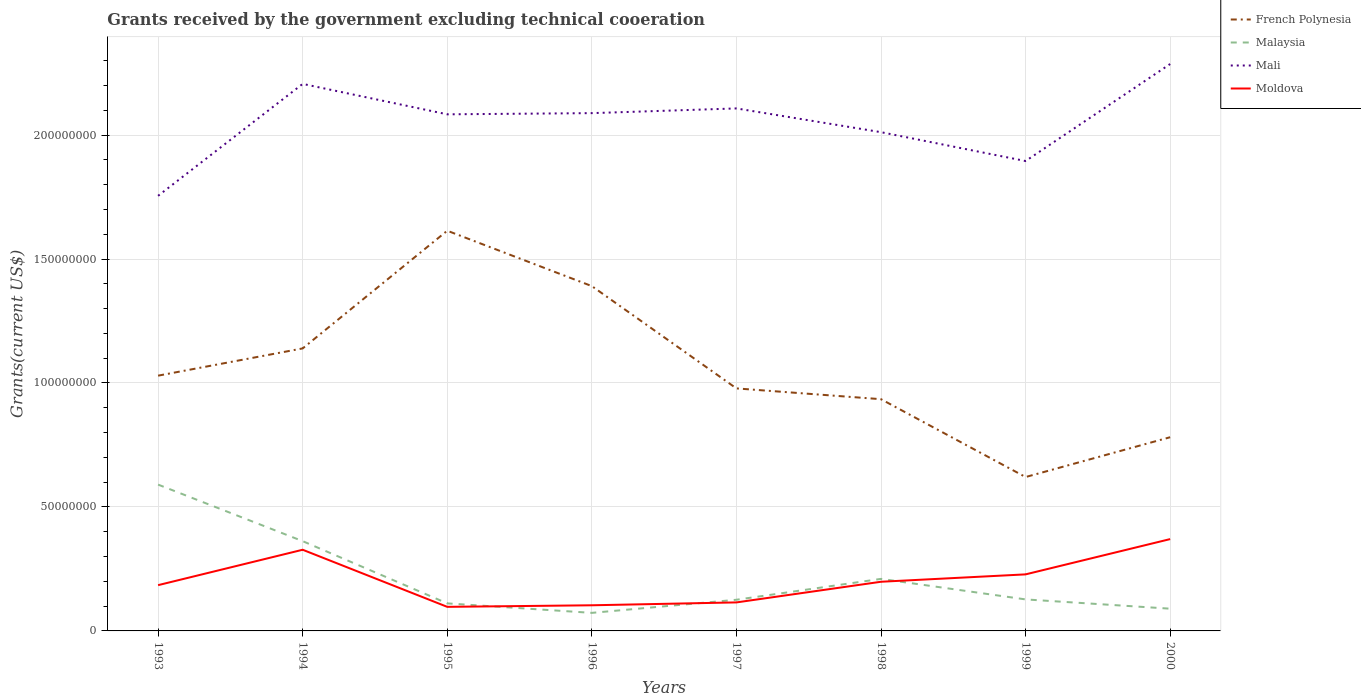How many different coloured lines are there?
Offer a terse response. 4. Does the line corresponding to Malaysia intersect with the line corresponding to French Polynesia?
Offer a terse response. No. Across all years, what is the maximum total grants received by the government in Moldova?
Your answer should be compact. 9.71e+06. What is the total total grants received by the government in Mali in the graph?
Make the answer very short. 7.68e+06. What is the difference between the highest and the second highest total grants received by the government in Moldova?
Give a very brief answer. 2.73e+07. Is the total grants received by the government in Mali strictly greater than the total grants received by the government in French Polynesia over the years?
Provide a succinct answer. No. What is the difference between two consecutive major ticks on the Y-axis?
Your response must be concise. 5.00e+07. Does the graph contain any zero values?
Your answer should be compact. No. Does the graph contain grids?
Make the answer very short. Yes. Where does the legend appear in the graph?
Make the answer very short. Top right. How many legend labels are there?
Your response must be concise. 4. How are the legend labels stacked?
Offer a very short reply. Vertical. What is the title of the graph?
Your answer should be compact. Grants received by the government excluding technical cooeration. Does "Swaziland" appear as one of the legend labels in the graph?
Make the answer very short. No. What is the label or title of the Y-axis?
Your response must be concise. Grants(current US$). What is the Grants(current US$) in French Polynesia in 1993?
Your answer should be compact. 1.03e+08. What is the Grants(current US$) in Malaysia in 1993?
Your answer should be very brief. 5.90e+07. What is the Grants(current US$) in Mali in 1993?
Offer a terse response. 1.76e+08. What is the Grants(current US$) in Moldova in 1993?
Offer a very short reply. 1.85e+07. What is the Grants(current US$) in French Polynesia in 1994?
Your response must be concise. 1.14e+08. What is the Grants(current US$) of Malaysia in 1994?
Your answer should be very brief. 3.62e+07. What is the Grants(current US$) of Mali in 1994?
Offer a very short reply. 2.21e+08. What is the Grants(current US$) of Moldova in 1994?
Provide a succinct answer. 3.27e+07. What is the Grants(current US$) of French Polynesia in 1995?
Keep it short and to the point. 1.61e+08. What is the Grants(current US$) in Malaysia in 1995?
Keep it short and to the point. 1.11e+07. What is the Grants(current US$) of Mali in 1995?
Your answer should be compact. 2.08e+08. What is the Grants(current US$) in Moldova in 1995?
Your response must be concise. 9.71e+06. What is the Grants(current US$) in French Polynesia in 1996?
Your response must be concise. 1.39e+08. What is the Grants(current US$) in Malaysia in 1996?
Your answer should be very brief. 7.28e+06. What is the Grants(current US$) of Mali in 1996?
Offer a terse response. 2.09e+08. What is the Grants(current US$) of Moldova in 1996?
Your response must be concise. 1.03e+07. What is the Grants(current US$) of French Polynesia in 1997?
Keep it short and to the point. 9.78e+07. What is the Grants(current US$) in Malaysia in 1997?
Your answer should be compact. 1.26e+07. What is the Grants(current US$) of Mali in 1997?
Provide a succinct answer. 2.11e+08. What is the Grants(current US$) in Moldova in 1997?
Offer a very short reply. 1.15e+07. What is the Grants(current US$) of French Polynesia in 1998?
Offer a terse response. 9.35e+07. What is the Grants(current US$) of Malaysia in 1998?
Ensure brevity in your answer.  2.10e+07. What is the Grants(current US$) in Mali in 1998?
Provide a succinct answer. 2.01e+08. What is the Grants(current US$) in Moldova in 1998?
Ensure brevity in your answer.  1.98e+07. What is the Grants(current US$) of French Polynesia in 1999?
Your answer should be compact. 6.21e+07. What is the Grants(current US$) of Malaysia in 1999?
Provide a succinct answer. 1.27e+07. What is the Grants(current US$) in Mali in 1999?
Your answer should be very brief. 1.90e+08. What is the Grants(current US$) in Moldova in 1999?
Your response must be concise. 2.28e+07. What is the Grants(current US$) in French Polynesia in 2000?
Your answer should be very brief. 7.81e+07. What is the Grants(current US$) in Malaysia in 2000?
Your response must be concise. 8.97e+06. What is the Grants(current US$) of Mali in 2000?
Your answer should be very brief. 2.29e+08. What is the Grants(current US$) of Moldova in 2000?
Your response must be concise. 3.70e+07. Across all years, what is the maximum Grants(current US$) of French Polynesia?
Provide a succinct answer. 1.61e+08. Across all years, what is the maximum Grants(current US$) of Malaysia?
Provide a short and direct response. 5.90e+07. Across all years, what is the maximum Grants(current US$) in Mali?
Give a very brief answer. 2.29e+08. Across all years, what is the maximum Grants(current US$) of Moldova?
Ensure brevity in your answer.  3.70e+07. Across all years, what is the minimum Grants(current US$) in French Polynesia?
Your answer should be compact. 6.21e+07. Across all years, what is the minimum Grants(current US$) in Malaysia?
Provide a short and direct response. 7.28e+06. Across all years, what is the minimum Grants(current US$) of Mali?
Keep it short and to the point. 1.76e+08. Across all years, what is the minimum Grants(current US$) in Moldova?
Your response must be concise. 9.71e+06. What is the total Grants(current US$) of French Polynesia in the graph?
Provide a short and direct response. 8.49e+08. What is the total Grants(current US$) of Malaysia in the graph?
Make the answer very short. 1.69e+08. What is the total Grants(current US$) in Mali in the graph?
Your answer should be compact. 1.64e+09. What is the total Grants(current US$) of Moldova in the graph?
Offer a very short reply. 1.62e+08. What is the difference between the Grants(current US$) in French Polynesia in 1993 and that in 1994?
Your answer should be very brief. -1.10e+07. What is the difference between the Grants(current US$) in Malaysia in 1993 and that in 1994?
Make the answer very short. 2.28e+07. What is the difference between the Grants(current US$) of Mali in 1993 and that in 1994?
Ensure brevity in your answer.  -4.51e+07. What is the difference between the Grants(current US$) of Moldova in 1993 and that in 1994?
Give a very brief answer. -1.43e+07. What is the difference between the Grants(current US$) in French Polynesia in 1993 and that in 1995?
Keep it short and to the point. -5.85e+07. What is the difference between the Grants(current US$) in Malaysia in 1993 and that in 1995?
Offer a very short reply. 4.79e+07. What is the difference between the Grants(current US$) in Mali in 1993 and that in 1995?
Make the answer very short. -3.29e+07. What is the difference between the Grants(current US$) of Moldova in 1993 and that in 1995?
Your response must be concise. 8.75e+06. What is the difference between the Grants(current US$) in French Polynesia in 1993 and that in 1996?
Give a very brief answer. -3.61e+07. What is the difference between the Grants(current US$) in Malaysia in 1993 and that in 1996?
Provide a succinct answer. 5.17e+07. What is the difference between the Grants(current US$) in Mali in 1993 and that in 1996?
Ensure brevity in your answer.  -3.34e+07. What is the difference between the Grants(current US$) in Moldova in 1993 and that in 1996?
Offer a very short reply. 8.12e+06. What is the difference between the Grants(current US$) of French Polynesia in 1993 and that in 1997?
Provide a short and direct response. 5.14e+06. What is the difference between the Grants(current US$) of Malaysia in 1993 and that in 1997?
Your response must be concise. 4.64e+07. What is the difference between the Grants(current US$) of Mali in 1993 and that in 1997?
Your answer should be compact. -3.52e+07. What is the difference between the Grants(current US$) of Moldova in 1993 and that in 1997?
Keep it short and to the point. 6.96e+06. What is the difference between the Grants(current US$) of French Polynesia in 1993 and that in 1998?
Your answer should be very brief. 9.49e+06. What is the difference between the Grants(current US$) of Malaysia in 1993 and that in 1998?
Keep it short and to the point. 3.80e+07. What is the difference between the Grants(current US$) in Mali in 1993 and that in 1998?
Ensure brevity in your answer.  -2.57e+07. What is the difference between the Grants(current US$) in Moldova in 1993 and that in 1998?
Give a very brief answer. -1.37e+06. What is the difference between the Grants(current US$) in French Polynesia in 1993 and that in 1999?
Give a very brief answer. 4.09e+07. What is the difference between the Grants(current US$) of Malaysia in 1993 and that in 1999?
Provide a succinct answer. 4.63e+07. What is the difference between the Grants(current US$) in Mali in 1993 and that in 1999?
Offer a very short reply. -1.40e+07. What is the difference between the Grants(current US$) in Moldova in 1993 and that in 1999?
Provide a short and direct response. -4.35e+06. What is the difference between the Grants(current US$) of French Polynesia in 1993 and that in 2000?
Your answer should be very brief. 2.48e+07. What is the difference between the Grants(current US$) in Malaysia in 1993 and that in 2000?
Offer a very short reply. 5.00e+07. What is the difference between the Grants(current US$) of Mali in 1993 and that in 2000?
Your answer should be very brief. -5.32e+07. What is the difference between the Grants(current US$) in Moldova in 1993 and that in 2000?
Ensure brevity in your answer.  -1.86e+07. What is the difference between the Grants(current US$) of French Polynesia in 1994 and that in 1995?
Your response must be concise. -4.75e+07. What is the difference between the Grants(current US$) of Malaysia in 1994 and that in 1995?
Offer a very short reply. 2.51e+07. What is the difference between the Grants(current US$) in Mali in 1994 and that in 1995?
Your answer should be very brief. 1.23e+07. What is the difference between the Grants(current US$) in Moldova in 1994 and that in 1995?
Offer a terse response. 2.30e+07. What is the difference between the Grants(current US$) in French Polynesia in 1994 and that in 1996?
Keep it short and to the point. -2.51e+07. What is the difference between the Grants(current US$) of Malaysia in 1994 and that in 1996?
Your response must be concise. 2.89e+07. What is the difference between the Grants(current US$) in Mali in 1994 and that in 1996?
Ensure brevity in your answer.  1.18e+07. What is the difference between the Grants(current US$) of Moldova in 1994 and that in 1996?
Give a very brief answer. 2.24e+07. What is the difference between the Grants(current US$) of French Polynesia in 1994 and that in 1997?
Your answer should be compact. 1.61e+07. What is the difference between the Grants(current US$) in Malaysia in 1994 and that in 1997?
Your answer should be very brief. 2.36e+07. What is the difference between the Grants(current US$) of Mali in 1994 and that in 1997?
Your response must be concise. 9.89e+06. What is the difference between the Grants(current US$) in Moldova in 1994 and that in 1997?
Provide a succinct answer. 2.12e+07. What is the difference between the Grants(current US$) of French Polynesia in 1994 and that in 1998?
Provide a short and direct response. 2.05e+07. What is the difference between the Grants(current US$) of Malaysia in 1994 and that in 1998?
Your answer should be very brief. 1.52e+07. What is the difference between the Grants(current US$) in Mali in 1994 and that in 1998?
Give a very brief answer. 1.95e+07. What is the difference between the Grants(current US$) of Moldova in 1994 and that in 1998?
Keep it short and to the point. 1.29e+07. What is the difference between the Grants(current US$) of French Polynesia in 1994 and that in 1999?
Your response must be concise. 5.19e+07. What is the difference between the Grants(current US$) in Malaysia in 1994 and that in 1999?
Provide a succinct answer. 2.35e+07. What is the difference between the Grants(current US$) in Mali in 1994 and that in 1999?
Offer a terse response. 3.11e+07. What is the difference between the Grants(current US$) in Moldova in 1994 and that in 1999?
Provide a succinct answer. 9.93e+06. What is the difference between the Grants(current US$) in French Polynesia in 1994 and that in 2000?
Provide a succinct answer. 3.58e+07. What is the difference between the Grants(current US$) of Malaysia in 1994 and that in 2000?
Offer a terse response. 2.72e+07. What is the difference between the Grants(current US$) in Mali in 1994 and that in 2000?
Give a very brief answer. -8.02e+06. What is the difference between the Grants(current US$) in Moldova in 1994 and that in 2000?
Keep it short and to the point. -4.30e+06. What is the difference between the Grants(current US$) of French Polynesia in 1995 and that in 1996?
Keep it short and to the point. 2.23e+07. What is the difference between the Grants(current US$) of Malaysia in 1995 and that in 1996?
Offer a terse response. 3.83e+06. What is the difference between the Grants(current US$) in Mali in 1995 and that in 1996?
Provide a succinct answer. -4.80e+05. What is the difference between the Grants(current US$) of Moldova in 1995 and that in 1996?
Your response must be concise. -6.30e+05. What is the difference between the Grants(current US$) of French Polynesia in 1995 and that in 1997?
Offer a terse response. 6.36e+07. What is the difference between the Grants(current US$) of Malaysia in 1995 and that in 1997?
Keep it short and to the point. -1.46e+06. What is the difference between the Grants(current US$) of Mali in 1995 and that in 1997?
Your response must be concise. -2.38e+06. What is the difference between the Grants(current US$) of Moldova in 1995 and that in 1997?
Offer a very short reply. -1.79e+06. What is the difference between the Grants(current US$) of French Polynesia in 1995 and that in 1998?
Your response must be concise. 6.80e+07. What is the difference between the Grants(current US$) of Malaysia in 1995 and that in 1998?
Offer a terse response. -9.88e+06. What is the difference between the Grants(current US$) of Mali in 1995 and that in 1998?
Offer a terse response. 7.20e+06. What is the difference between the Grants(current US$) of Moldova in 1995 and that in 1998?
Offer a terse response. -1.01e+07. What is the difference between the Grants(current US$) of French Polynesia in 1995 and that in 1999?
Make the answer very short. 9.94e+07. What is the difference between the Grants(current US$) in Malaysia in 1995 and that in 1999?
Make the answer very short. -1.60e+06. What is the difference between the Grants(current US$) in Mali in 1995 and that in 1999?
Your answer should be compact. 1.88e+07. What is the difference between the Grants(current US$) of Moldova in 1995 and that in 1999?
Give a very brief answer. -1.31e+07. What is the difference between the Grants(current US$) in French Polynesia in 1995 and that in 2000?
Your answer should be very brief. 8.33e+07. What is the difference between the Grants(current US$) of Malaysia in 1995 and that in 2000?
Provide a succinct answer. 2.14e+06. What is the difference between the Grants(current US$) in Mali in 1995 and that in 2000?
Offer a terse response. -2.03e+07. What is the difference between the Grants(current US$) in Moldova in 1995 and that in 2000?
Offer a very short reply. -2.73e+07. What is the difference between the Grants(current US$) of French Polynesia in 1996 and that in 1997?
Give a very brief answer. 4.13e+07. What is the difference between the Grants(current US$) of Malaysia in 1996 and that in 1997?
Provide a succinct answer. -5.29e+06. What is the difference between the Grants(current US$) of Mali in 1996 and that in 1997?
Your answer should be compact. -1.90e+06. What is the difference between the Grants(current US$) of Moldova in 1996 and that in 1997?
Make the answer very short. -1.16e+06. What is the difference between the Grants(current US$) of French Polynesia in 1996 and that in 1998?
Your answer should be very brief. 4.56e+07. What is the difference between the Grants(current US$) in Malaysia in 1996 and that in 1998?
Provide a succinct answer. -1.37e+07. What is the difference between the Grants(current US$) of Mali in 1996 and that in 1998?
Your answer should be very brief. 7.68e+06. What is the difference between the Grants(current US$) in Moldova in 1996 and that in 1998?
Offer a terse response. -9.49e+06. What is the difference between the Grants(current US$) in French Polynesia in 1996 and that in 1999?
Your answer should be compact. 7.70e+07. What is the difference between the Grants(current US$) in Malaysia in 1996 and that in 1999?
Offer a very short reply. -5.43e+06. What is the difference between the Grants(current US$) in Mali in 1996 and that in 1999?
Provide a short and direct response. 1.93e+07. What is the difference between the Grants(current US$) of Moldova in 1996 and that in 1999?
Give a very brief answer. -1.25e+07. What is the difference between the Grants(current US$) of French Polynesia in 1996 and that in 2000?
Keep it short and to the point. 6.10e+07. What is the difference between the Grants(current US$) of Malaysia in 1996 and that in 2000?
Give a very brief answer. -1.69e+06. What is the difference between the Grants(current US$) in Mali in 1996 and that in 2000?
Provide a succinct answer. -1.98e+07. What is the difference between the Grants(current US$) of Moldova in 1996 and that in 2000?
Provide a succinct answer. -2.67e+07. What is the difference between the Grants(current US$) in French Polynesia in 1997 and that in 1998?
Provide a succinct answer. 4.35e+06. What is the difference between the Grants(current US$) in Malaysia in 1997 and that in 1998?
Provide a short and direct response. -8.42e+06. What is the difference between the Grants(current US$) in Mali in 1997 and that in 1998?
Offer a terse response. 9.58e+06. What is the difference between the Grants(current US$) in Moldova in 1997 and that in 1998?
Offer a very short reply. -8.33e+06. What is the difference between the Grants(current US$) of French Polynesia in 1997 and that in 1999?
Make the answer very short. 3.58e+07. What is the difference between the Grants(current US$) of Malaysia in 1997 and that in 1999?
Your answer should be very brief. -1.40e+05. What is the difference between the Grants(current US$) in Mali in 1997 and that in 1999?
Provide a succinct answer. 2.12e+07. What is the difference between the Grants(current US$) in Moldova in 1997 and that in 1999?
Your answer should be very brief. -1.13e+07. What is the difference between the Grants(current US$) in French Polynesia in 1997 and that in 2000?
Provide a short and direct response. 1.97e+07. What is the difference between the Grants(current US$) of Malaysia in 1997 and that in 2000?
Your answer should be very brief. 3.60e+06. What is the difference between the Grants(current US$) in Mali in 1997 and that in 2000?
Offer a very short reply. -1.79e+07. What is the difference between the Grants(current US$) of Moldova in 1997 and that in 2000?
Offer a very short reply. -2.55e+07. What is the difference between the Grants(current US$) of French Polynesia in 1998 and that in 1999?
Your answer should be very brief. 3.14e+07. What is the difference between the Grants(current US$) of Malaysia in 1998 and that in 1999?
Provide a short and direct response. 8.28e+06. What is the difference between the Grants(current US$) of Mali in 1998 and that in 1999?
Provide a short and direct response. 1.16e+07. What is the difference between the Grants(current US$) in Moldova in 1998 and that in 1999?
Provide a succinct answer. -2.98e+06. What is the difference between the Grants(current US$) of French Polynesia in 1998 and that in 2000?
Your response must be concise. 1.53e+07. What is the difference between the Grants(current US$) in Malaysia in 1998 and that in 2000?
Provide a succinct answer. 1.20e+07. What is the difference between the Grants(current US$) in Mali in 1998 and that in 2000?
Make the answer very short. -2.75e+07. What is the difference between the Grants(current US$) of Moldova in 1998 and that in 2000?
Make the answer very short. -1.72e+07. What is the difference between the Grants(current US$) in French Polynesia in 1999 and that in 2000?
Ensure brevity in your answer.  -1.61e+07. What is the difference between the Grants(current US$) in Malaysia in 1999 and that in 2000?
Provide a short and direct response. 3.74e+06. What is the difference between the Grants(current US$) in Mali in 1999 and that in 2000?
Your answer should be compact. -3.91e+07. What is the difference between the Grants(current US$) of Moldova in 1999 and that in 2000?
Give a very brief answer. -1.42e+07. What is the difference between the Grants(current US$) in French Polynesia in 1993 and the Grants(current US$) in Malaysia in 1994?
Ensure brevity in your answer.  6.68e+07. What is the difference between the Grants(current US$) of French Polynesia in 1993 and the Grants(current US$) of Mali in 1994?
Your answer should be very brief. -1.18e+08. What is the difference between the Grants(current US$) of French Polynesia in 1993 and the Grants(current US$) of Moldova in 1994?
Provide a short and direct response. 7.02e+07. What is the difference between the Grants(current US$) in Malaysia in 1993 and the Grants(current US$) in Mali in 1994?
Provide a short and direct response. -1.62e+08. What is the difference between the Grants(current US$) in Malaysia in 1993 and the Grants(current US$) in Moldova in 1994?
Keep it short and to the point. 2.63e+07. What is the difference between the Grants(current US$) in Mali in 1993 and the Grants(current US$) in Moldova in 1994?
Your answer should be compact. 1.43e+08. What is the difference between the Grants(current US$) of French Polynesia in 1993 and the Grants(current US$) of Malaysia in 1995?
Provide a succinct answer. 9.18e+07. What is the difference between the Grants(current US$) in French Polynesia in 1993 and the Grants(current US$) in Mali in 1995?
Offer a very short reply. -1.05e+08. What is the difference between the Grants(current US$) of French Polynesia in 1993 and the Grants(current US$) of Moldova in 1995?
Ensure brevity in your answer.  9.32e+07. What is the difference between the Grants(current US$) of Malaysia in 1993 and the Grants(current US$) of Mali in 1995?
Give a very brief answer. -1.49e+08. What is the difference between the Grants(current US$) in Malaysia in 1993 and the Grants(current US$) in Moldova in 1995?
Give a very brief answer. 4.93e+07. What is the difference between the Grants(current US$) in Mali in 1993 and the Grants(current US$) in Moldova in 1995?
Your response must be concise. 1.66e+08. What is the difference between the Grants(current US$) in French Polynesia in 1993 and the Grants(current US$) in Malaysia in 1996?
Your response must be concise. 9.57e+07. What is the difference between the Grants(current US$) of French Polynesia in 1993 and the Grants(current US$) of Mali in 1996?
Make the answer very short. -1.06e+08. What is the difference between the Grants(current US$) in French Polynesia in 1993 and the Grants(current US$) in Moldova in 1996?
Ensure brevity in your answer.  9.26e+07. What is the difference between the Grants(current US$) of Malaysia in 1993 and the Grants(current US$) of Mali in 1996?
Offer a very short reply. -1.50e+08. What is the difference between the Grants(current US$) in Malaysia in 1993 and the Grants(current US$) in Moldova in 1996?
Your response must be concise. 4.87e+07. What is the difference between the Grants(current US$) in Mali in 1993 and the Grants(current US$) in Moldova in 1996?
Provide a short and direct response. 1.65e+08. What is the difference between the Grants(current US$) in French Polynesia in 1993 and the Grants(current US$) in Malaysia in 1997?
Keep it short and to the point. 9.04e+07. What is the difference between the Grants(current US$) in French Polynesia in 1993 and the Grants(current US$) in Mali in 1997?
Your answer should be compact. -1.08e+08. What is the difference between the Grants(current US$) of French Polynesia in 1993 and the Grants(current US$) of Moldova in 1997?
Make the answer very short. 9.15e+07. What is the difference between the Grants(current US$) in Malaysia in 1993 and the Grants(current US$) in Mali in 1997?
Your answer should be very brief. -1.52e+08. What is the difference between the Grants(current US$) in Malaysia in 1993 and the Grants(current US$) in Moldova in 1997?
Your answer should be compact. 4.75e+07. What is the difference between the Grants(current US$) in Mali in 1993 and the Grants(current US$) in Moldova in 1997?
Your answer should be compact. 1.64e+08. What is the difference between the Grants(current US$) in French Polynesia in 1993 and the Grants(current US$) in Malaysia in 1998?
Offer a terse response. 8.20e+07. What is the difference between the Grants(current US$) in French Polynesia in 1993 and the Grants(current US$) in Mali in 1998?
Keep it short and to the point. -9.82e+07. What is the difference between the Grants(current US$) in French Polynesia in 1993 and the Grants(current US$) in Moldova in 1998?
Your response must be concise. 8.31e+07. What is the difference between the Grants(current US$) in Malaysia in 1993 and the Grants(current US$) in Mali in 1998?
Give a very brief answer. -1.42e+08. What is the difference between the Grants(current US$) of Malaysia in 1993 and the Grants(current US$) of Moldova in 1998?
Your answer should be very brief. 3.92e+07. What is the difference between the Grants(current US$) of Mali in 1993 and the Grants(current US$) of Moldova in 1998?
Ensure brevity in your answer.  1.56e+08. What is the difference between the Grants(current US$) in French Polynesia in 1993 and the Grants(current US$) in Malaysia in 1999?
Make the answer very short. 9.02e+07. What is the difference between the Grants(current US$) in French Polynesia in 1993 and the Grants(current US$) in Mali in 1999?
Give a very brief answer. -8.66e+07. What is the difference between the Grants(current US$) in French Polynesia in 1993 and the Grants(current US$) in Moldova in 1999?
Your answer should be very brief. 8.02e+07. What is the difference between the Grants(current US$) of Malaysia in 1993 and the Grants(current US$) of Mali in 1999?
Offer a very short reply. -1.31e+08. What is the difference between the Grants(current US$) of Malaysia in 1993 and the Grants(current US$) of Moldova in 1999?
Keep it short and to the point. 3.62e+07. What is the difference between the Grants(current US$) of Mali in 1993 and the Grants(current US$) of Moldova in 1999?
Your answer should be compact. 1.53e+08. What is the difference between the Grants(current US$) of French Polynesia in 1993 and the Grants(current US$) of Malaysia in 2000?
Ensure brevity in your answer.  9.40e+07. What is the difference between the Grants(current US$) of French Polynesia in 1993 and the Grants(current US$) of Mali in 2000?
Offer a very short reply. -1.26e+08. What is the difference between the Grants(current US$) of French Polynesia in 1993 and the Grants(current US$) of Moldova in 2000?
Offer a very short reply. 6.59e+07. What is the difference between the Grants(current US$) in Malaysia in 1993 and the Grants(current US$) in Mali in 2000?
Offer a very short reply. -1.70e+08. What is the difference between the Grants(current US$) in Malaysia in 1993 and the Grants(current US$) in Moldova in 2000?
Provide a short and direct response. 2.20e+07. What is the difference between the Grants(current US$) of Mali in 1993 and the Grants(current US$) of Moldova in 2000?
Offer a very short reply. 1.38e+08. What is the difference between the Grants(current US$) in French Polynesia in 1994 and the Grants(current US$) in Malaysia in 1995?
Your answer should be very brief. 1.03e+08. What is the difference between the Grants(current US$) of French Polynesia in 1994 and the Grants(current US$) of Mali in 1995?
Ensure brevity in your answer.  -9.44e+07. What is the difference between the Grants(current US$) in French Polynesia in 1994 and the Grants(current US$) in Moldova in 1995?
Keep it short and to the point. 1.04e+08. What is the difference between the Grants(current US$) of Malaysia in 1994 and the Grants(current US$) of Mali in 1995?
Offer a terse response. -1.72e+08. What is the difference between the Grants(current US$) of Malaysia in 1994 and the Grants(current US$) of Moldova in 1995?
Give a very brief answer. 2.65e+07. What is the difference between the Grants(current US$) of Mali in 1994 and the Grants(current US$) of Moldova in 1995?
Keep it short and to the point. 2.11e+08. What is the difference between the Grants(current US$) of French Polynesia in 1994 and the Grants(current US$) of Malaysia in 1996?
Provide a short and direct response. 1.07e+08. What is the difference between the Grants(current US$) of French Polynesia in 1994 and the Grants(current US$) of Mali in 1996?
Give a very brief answer. -9.49e+07. What is the difference between the Grants(current US$) of French Polynesia in 1994 and the Grants(current US$) of Moldova in 1996?
Provide a short and direct response. 1.04e+08. What is the difference between the Grants(current US$) in Malaysia in 1994 and the Grants(current US$) in Mali in 1996?
Your answer should be very brief. -1.73e+08. What is the difference between the Grants(current US$) in Malaysia in 1994 and the Grants(current US$) in Moldova in 1996?
Keep it short and to the point. 2.59e+07. What is the difference between the Grants(current US$) in Mali in 1994 and the Grants(current US$) in Moldova in 1996?
Your response must be concise. 2.10e+08. What is the difference between the Grants(current US$) of French Polynesia in 1994 and the Grants(current US$) of Malaysia in 1997?
Make the answer very short. 1.01e+08. What is the difference between the Grants(current US$) of French Polynesia in 1994 and the Grants(current US$) of Mali in 1997?
Your answer should be compact. -9.68e+07. What is the difference between the Grants(current US$) in French Polynesia in 1994 and the Grants(current US$) in Moldova in 1997?
Provide a short and direct response. 1.02e+08. What is the difference between the Grants(current US$) of Malaysia in 1994 and the Grants(current US$) of Mali in 1997?
Your answer should be very brief. -1.75e+08. What is the difference between the Grants(current US$) of Malaysia in 1994 and the Grants(current US$) of Moldova in 1997?
Provide a succinct answer. 2.47e+07. What is the difference between the Grants(current US$) in Mali in 1994 and the Grants(current US$) in Moldova in 1997?
Offer a very short reply. 2.09e+08. What is the difference between the Grants(current US$) of French Polynesia in 1994 and the Grants(current US$) of Malaysia in 1998?
Keep it short and to the point. 9.30e+07. What is the difference between the Grants(current US$) in French Polynesia in 1994 and the Grants(current US$) in Mali in 1998?
Make the answer very short. -8.72e+07. What is the difference between the Grants(current US$) of French Polynesia in 1994 and the Grants(current US$) of Moldova in 1998?
Make the answer very short. 9.41e+07. What is the difference between the Grants(current US$) of Malaysia in 1994 and the Grants(current US$) of Mali in 1998?
Ensure brevity in your answer.  -1.65e+08. What is the difference between the Grants(current US$) in Malaysia in 1994 and the Grants(current US$) in Moldova in 1998?
Your answer should be very brief. 1.64e+07. What is the difference between the Grants(current US$) in Mali in 1994 and the Grants(current US$) in Moldova in 1998?
Ensure brevity in your answer.  2.01e+08. What is the difference between the Grants(current US$) of French Polynesia in 1994 and the Grants(current US$) of Malaysia in 1999?
Make the answer very short. 1.01e+08. What is the difference between the Grants(current US$) in French Polynesia in 1994 and the Grants(current US$) in Mali in 1999?
Ensure brevity in your answer.  -7.56e+07. What is the difference between the Grants(current US$) of French Polynesia in 1994 and the Grants(current US$) of Moldova in 1999?
Offer a very short reply. 9.11e+07. What is the difference between the Grants(current US$) in Malaysia in 1994 and the Grants(current US$) in Mali in 1999?
Provide a short and direct response. -1.53e+08. What is the difference between the Grants(current US$) in Malaysia in 1994 and the Grants(current US$) in Moldova in 1999?
Give a very brief answer. 1.34e+07. What is the difference between the Grants(current US$) in Mali in 1994 and the Grants(current US$) in Moldova in 1999?
Provide a succinct answer. 1.98e+08. What is the difference between the Grants(current US$) in French Polynesia in 1994 and the Grants(current US$) in Malaysia in 2000?
Your answer should be very brief. 1.05e+08. What is the difference between the Grants(current US$) of French Polynesia in 1994 and the Grants(current US$) of Mali in 2000?
Keep it short and to the point. -1.15e+08. What is the difference between the Grants(current US$) in French Polynesia in 1994 and the Grants(current US$) in Moldova in 2000?
Provide a succinct answer. 7.69e+07. What is the difference between the Grants(current US$) in Malaysia in 1994 and the Grants(current US$) in Mali in 2000?
Ensure brevity in your answer.  -1.92e+08. What is the difference between the Grants(current US$) of Malaysia in 1994 and the Grants(current US$) of Moldova in 2000?
Keep it short and to the point. -8.30e+05. What is the difference between the Grants(current US$) of Mali in 1994 and the Grants(current US$) of Moldova in 2000?
Give a very brief answer. 1.84e+08. What is the difference between the Grants(current US$) in French Polynesia in 1995 and the Grants(current US$) in Malaysia in 1996?
Provide a short and direct response. 1.54e+08. What is the difference between the Grants(current US$) of French Polynesia in 1995 and the Grants(current US$) of Mali in 1996?
Ensure brevity in your answer.  -4.74e+07. What is the difference between the Grants(current US$) of French Polynesia in 1995 and the Grants(current US$) of Moldova in 1996?
Make the answer very short. 1.51e+08. What is the difference between the Grants(current US$) in Malaysia in 1995 and the Grants(current US$) in Mali in 1996?
Give a very brief answer. -1.98e+08. What is the difference between the Grants(current US$) in Malaysia in 1995 and the Grants(current US$) in Moldova in 1996?
Give a very brief answer. 7.70e+05. What is the difference between the Grants(current US$) in Mali in 1995 and the Grants(current US$) in Moldova in 1996?
Your answer should be very brief. 1.98e+08. What is the difference between the Grants(current US$) in French Polynesia in 1995 and the Grants(current US$) in Malaysia in 1997?
Offer a terse response. 1.49e+08. What is the difference between the Grants(current US$) of French Polynesia in 1995 and the Grants(current US$) of Mali in 1997?
Ensure brevity in your answer.  -4.93e+07. What is the difference between the Grants(current US$) of French Polynesia in 1995 and the Grants(current US$) of Moldova in 1997?
Provide a succinct answer. 1.50e+08. What is the difference between the Grants(current US$) in Malaysia in 1995 and the Grants(current US$) in Mali in 1997?
Offer a very short reply. -2.00e+08. What is the difference between the Grants(current US$) of Malaysia in 1995 and the Grants(current US$) of Moldova in 1997?
Ensure brevity in your answer.  -3.90e+05. What is the difference between the Grants(current US$) of Mali in 1995 and the Grants(current US$) of Moldova in 1997?
Ensure brevity in your answer.  1.97e+08. What is the difference between the Grants(current US$) of French Polynesia in 1995 and the Grants(current US$) of Malaysia in 1998?
Give a very brief answer. 1.40e+08. What is the difference between the Grants(current US$) in French Polynesia in 1995 and the Grants(current US$) in Mali in 1998?
Give a very brief answer. -3.98e+07. What is the difference between the Grants(current US$) of French Polynesia in 1995 and the Grants(current US$) of Moldova in 1998?
Ensure brevity in your answer.  1.42e+08. What is the difference between the Grants(current US$) in Malaysia in 1995 and the Grants(current US$) in Mali in 1998?
Ensure brevity in your answer.  -1.90e+08. What is the difference between the Grants(current US$) of Malaysia in 1995 and the Grants(current US$) of Moldova in 1998?
Your answer should be compact. -8.72e+06. What is the difference between the Grants(current US$) in Mali in 1995 and the Grants(current US$) in Moldova in 1998?
Ensure brevity in your answer.  1.89e+08. What is the difference between the Grants(current US$) of French Polynesia in 1995 and the Grants(current US$) of Malaysia in 1999?
Your response must be concise. 1.49e+08. What is the difference between the Grants(current US$) in French Polynesia in 1995 and the Grants(current US$) in Mali in 1999?
Provide a succinct answer. -2.81e+07. What is the difference between the Grants(current US$) of French Polynesia in 1995 and the Grants(current US$) of Moldova in 1999?
Provide a short and direct response. 1.39e+08. What is the difference between the Grants(current US$) of Malaysia in 1995 and the Grants(current US$) of Mali in 1999?
Offer a terse response. -1.78e+08. What is the difference between the Grants(current US$) of Malaysia in 1995 and the Grants(current US$) of Moldova in 1999?
Your response must be concise. -1.17e+07. What is the difference between the Grants(current US$) of Mali in 1995 and the Grants(current US$) of Moldova in 1999?
Your answer should be compact. 1.86e+08. What is the difference between the Grants(current US$) in French Polynesia in 1995 and the Grants(current US$) in Malaysia in 2000?
Give a very brief answer. 1.52e+08. What is the difference between the Grants(current US$) in French Polynesia in 1995 and the Grants(current US$) in Mali in 2000?
Provide a succinct answer. -6.72e+07. What is the difference between the Grants(current US$) of French Polynesia in 1995 and the Grants(current US$) of Moldova in 2000?
Make the answer very short. 1.24e+08. What is the difference between the Grants(current US$) in Malaysia in 1995 and the Grants(current US$) in Mali in 2000?
Make the answer very short. -2.18e+08. What is the difference between the Grants(current US$) of Malaysia in 1995 and the Grants(current US$) of Moldova in 2000?
Keep it short and to the point. -2.59e+07. What is the difference between the Grants(current US$) in Mali in 1995 and the Grants(current US$) in Moldova in 2000?
Give a very brief answer. 1.71e+08. What is the difference between the Grants(current US$) in French Polynesia in 1996 and the Grants(current US$) in Malaysia in 1997?
Offer a terse response. 1.27e+08. What is the difference between the Grants(current US$) in French Polynesia in 1996 and the Grants(current US$) in Mali in 1997?
Provide a succinct answer. -7.17e+07. What is the difference between the Grants(current US$) in French Polynesia in 1996 and the Grants(current US$) in Moldova in 1997?
Give a very brief answer. 1.28e+08. What is the difference between the Grants(current US$) of Malaysia in 1996 and the Grants(current US$) of Mali in 1997?
Your response must be concise. -2.03e+08. What is the difference between the Grants(current US$) of Malaysia in 1996 and the Grants(current US$) of Moldova in 1997?
Provide a short and direct response. -4.22e+06. What is the difference between the Grants(current US$) of Mali in 1996 and the Grants(current US$) of Moldova in 1997?
Offer a terse response. 1.97e+08. What is the difference between the Grants(current US$) of French Polynesia in 1996 and the Grants(current US$) of Malaysia in 1998?
Ensure brevity in your answer.  1.18e+08. What is the difference between the Grants(current US$) in French Polynesia in 1996 and the Grants(current US$) in Mali in 1998?
Ensure brevity in your answer.  -6.21e+07. What is the difference between the Grants(current US$) of French Polynesia in 1996 and the Grants(current US$) of Moldova in 1998?
Provide a succinct answer. 1.19e+08. What is the difference between the Grants(current US$) of Malaysia in 1996 and the Grants(current US$) of Mali in 1998?
Give a very brief answer. -1.94e+08. What is the difference between the Grants(current US$) in Malaysia in 1996 and the Grants(current US$) in Moldova in 1998?
Keep it short and to the point. -1.26e+07. What is the difference between the Grants(current US$) in Mali in 1996 and the Grants(current US$) in Moldova in 1998?
Keep it short and to the point. 1.89e+08. What is the difference between the Grants(current US$) in French Polynesia in 1996 and the Grants(current US$) in Malaysia in 1999?
Keep it short and to the point. 1.26e+08. What is the difference between the Grants(current US$) in French Polynesia in 1996 and the Grants(current US$) in Mali in 1999?
Provide a succinct answer. -5.04e+07. What is the difference between the Grants(current US$) of French Polynesia in 1996 and the Grants(current US$) of Moldova in 1999?
Your answer should be very brief. 1.16e+08. What is the difference between the Grants(current US$) in Malaysia in 1996 and the Grants(current US$) in Mali in 1999?
Provide a succinct answer. -1.82e+08. What is the difference between the Grants(current US$) in Malaysia in 1996 and the Grants(current US$) in Moldova in 1999?
Offer a terse response. -1.55e+07. What is the difference between the Grants(current US$) of Mali in 1996 and the Grants(current US$) of Moldova in 1999?
Your answer should be compact. 1.86e+08. What is the difference between the Grants(current US$) of French Polynesia in 1996 and the Grants(current US$) of Malaysia in 2000?
Offer a very short reply. 1.30e+08. What is the difference between the Grants(current US$) of French Polynesia in 1996 and the Grants(current US$) of Mali in 2000?
Provide a short and direct response. -8.96e+07. What is the difference between the Grants(current US$) of French Polynesia in 1996 and the Grants(current US$) of Moldova in 2000?
Your response must be concise. 1.02e+08. What is the difference between the Grants(current US$) of Malaysia in 1996 and the Grants(current US$) of Mali in 2000?
Provide a succinct answer. -2.21e+08. What is the difference between the Grants(current US$) of Malaysia in 1996 and the Grants(current US$) of Moldova in 2000?
Your answer should be compact. -2.98e+07. What is the difference between the Grants(current US$) of Mali in 1996 and the Grants(current US$) of Moldova in 2000?
Your answer should be very brief. 1.72e+08. What is the difference between the Grants(current US$) of French Polynesia in 1997 and the Grants(current US$) of Malaysia in 1998?
Offer a terse response. 7.68e+07. What is the difference between the Grants(current US$) of French Polynesia in 1997 and the Grants(current US$) of Mali in 1998?
Keep it short and to the point. -1.03e+08. What is the difference between the Grants(current US$) in French Polynesia in 1997 and the Grants(current US$) in Moldova in 1998?
Make the answer very short. 7.80e+07. What is the difference between the Grants(current US$) in Malaysia in 1997 and the Grants(current US$) in Mali in 1998?
Your answer should be compact. -1.89e+08. What is the difference between the Grants(current US$) in Malaysia in 1997 and the Grants(current US$) in Moldova in 1998?
Your answer should be very brief. -7.26e+06. What is the difference between the Grants(current US$) in Mali in 1997 and the Grants(current US$) in Moldova in 1998?
Offer a terse response. 1.91e+08. What is the difference between the Grants(current US$) in French Polynesia in 1997 and the Grants(current US$) in Malaysia in 1999?
Make the answer very short. 8.51e+07. What is the difference between the Grants(current US$) of French Polynesia in 1997 and the Grants(current US$) of Mali in 1999?
Ensure brevity in your answer.  -9.17e+07. What is the difference between the Grants(current US$) of French Polynesia in 1997 and the Grants(current US$) of Moldova in 1999?
Give a very brief answer. 7.50e+07. What is the difference between the Grants(current US$) in Malaysia in 1997 and the Grants(current US$) in Mali in 1999?
Make the answer very short. -1.77e+08. What is the difference between the Grants(current US$) in Malaysia in 1997 and the Grants(current US$) in Moldova in 1999?
Make the answer very short. -1.02e+07. What is the difference between the Grants(current US$) of Mali in 1997 and the Grants(current US$) of Moldova in 1999?
Give a very brief answer. 1.88e+08. What is the difference between the Grants(current US$) of French Polynesia in 1997 and the Grants(current US$) of Malaysia in 2000?
Your response must be concise. 8.88e+07. What is the difference between the Grants(current US$) of French Polynesia in 1997 and the Grants(current US$) of Mali in 2000?
Your answer should be compact. -1.31e+08. What is the difference between the Grants(current US$) of French Polynesia in 1997 and the Grants(current US$) of Moldova in 2000?
Keep it short and to the point. 6.08e+07. What is the difference between the Grants(current US$) of Malaysia in 1997 and the Grants(current US$) of Mali in 2000?
Offer a very short reply. -2.16e+08. What is the difference between the Grants(current US$) of Malaysia in 1997 and the Grants(current US$) of Moldova in 2000?
Your response must be concise. -2.45e+07. What is the difference between the Grants(current US$) in Mali in 1997 and the Grants(current US$) in Moldova in 2000?
Offer a very short reply. 1.74e+08. What is the difference between the Grants(current US$) of French Polynesia in 1998 and the Grants(current US$) of Malaysia in 1999?
Your answer should be very brief. 8.08e+07. What is the difference between the Grants(current US$) of French Polynesia in 1998 and the Grants(current US$) of Mali in 1999?
Keep it short and to the point. -9.61e+07. What is the difference between the Grants(current US$) of French Polynesia in 1998 and the Grants(current US$) of Moldova in 1999?
Provide a short and direct response. 7.07e+07. What is the difference between the Grants(current US$) of Malaysia in 1998 and the Grants(current US$) of Mali in 1999?
Provide a succinct answer. -1.69e+08. What is the difference between the Grants(current US$) in Malaysia in 1998 and the Grants(current US$) in Moldova in 1999?
Offer a very short reply. -1.82e+06. What is the difference between the Grants(current US$) in Mali in 1998 and the Grants(current US$) in Moldova in 1999?
Offer a terse response. 1.78e+08. What is the difference between the Grants(current US$) in French Polynesia in 1998 and the Grants(current US$) in Malaysia in 2000?
Your answer should be compact. 8.45e+07. What is the difference between the Grants(current US$) of French Polynesia in 1998 and the Grants(current US$) of Mali in 2000?
Your response must be concise. -1.35e+08. What is the difference between the Grants(current US$) in French Polynesia in 1998 and the Grants(current US$) in Moldova in 2000?
Your answer should be compact. 5.64e+07. What is the difference between the Grants(current US$) in Malaysia in 1998 and the Grants(current US$) in Mali in 2000?
Provide a short and direct response. -2.08e+08. What is the difference between the Grants(current US$) in Malaysia in 1998 and the Grants(current US$) in Moldova in 2000?
Your answer should be very brief. -1.60e+07. What is the difference between the Grants(current US$) of Mali in 1998 and the Grants(current US$) of Moldova in 2000?
Provide a short and direct response. 1.64e+08. What is the difference between the Grants(current US$) in French Polynesia in 1999 and the Grants(current US$) in Malaysia in 2000?
Ensure brevity in your answer.  5.31e+07. What is the difference between the Grants(current US$) of French Polynesia in 1999 and the Grants(current US$) of Mali in 2000?
Offer a terse response. -1.67e+08. What is the difference between the Grants(current US$) in French Polynesia in 1999 and the Grants(current US$) in Moldova in 2000?
Provide a short and direct response. 2.50e+07. What is the difference between the Grants(current US$) of Malaysia in 1999 and the Grants(current US$) of Mali in 2000?
Give a very brief answer. -2.16e+08. What is the difference between the Grants(current US$) of Malaysia in 1999 and the Grants(current US$) of Moldova in 2000?
Provide a succinct answer. -2.43e+07. What is the difference between the Grants(current US$) in Mali in 1999 and the Grants(current US$) in Moldova in 2000?
Provide a succinct answer. 1.52e+08. What is the average Grants(current US$) in French Polynesia per year?
Offer a very short reply. 1.06e+08. What is the average Grants(current US$) in Malaysia per year?
Your response must be concise. 2.11e+07. What is the average Grants(current US$) of Mali per year?
Offer a terse response. 2.05e+08. What is the average Grants(current US$) of Moldova per year?
Offer a very short reply. 2.03e+07. In the year 1993, what is the difference between the Grants(current US$) of French Polynesia and Grants(current US$) of Malaysia?
Keep it short and to the point. 4.39e+07. In the year 1993, what is the difference between the Grants(current US$) in French Polynesia and Grants(current US$) in Mali?
Offer a very short reply. -7.25e+07. In the year 1993, what is the difference between the Grants(current US$) in French Polynesia and Grants(current US$) in Moldova?
Give a very brief answer. 8.45e+07. In the year 1993, what is the difference between the Grants(current US$) in Malaysia and Grants(current US$) in Mali?
Your answer should be compact. -1.16e+08. In the year 1993, what is the difference between the Grants(current US$) of Malaysia and Grants(current US$) of Moldova?
Provide a short and direct response. 4.06e+07. In the year 1993, what is the difference between the Grants(current US$) in Mali and Grants(current US$) in Moldova?
Offer a very short reply. 1.57e+08. In the year 1994, what is the difference between the Grants(current US$) of French Polynesia and Grants(current US$) of Malaysia?
Your response must be concise. 7.77e+07. In the year 1994, what is the difference between the Grants(current US$) of French Polynesia and Grants(current US$) of Mali?
Give a very brief answer. -1.07e+08. In the year 1994, what is the difference between the Grants(current US$) of French Polynesia and Grants(current US$) of Moldova?
Ensure brevity in your answer.  8.12e+07. In the year 1994, what is the difference between the Grants(current US$) of Malaysia and Grants(current US$) of Mali?
Your answer should be compact. -1.84e+08. In the year 1994, what is the difference between the Grants(current US$) in Malaysia and Grants(current US$) in Moldova?
Keep it short and to the point. 3.47e+06. In the year 1994, what is the difference between the Grants(current US$) of Mali and Grants(current US$) of Moldova?
Provide a short and direct response. 1.88e+08. In the year 1995, what is the difference between the Grants(current US$) in French Polynesia and Grants(current US$) in Malaysia?
Make the answer very short. 1.50e+08. In the year 1995, what is the difference between the Grants(current US$) in French Polynesia and Grants(current US$) in Mali?
Make the answer very short. -4.70e+07. In the year 1995, what is the difference between the Grants(current US$) in French Polynesia and Grants(current US$) in Moldova?
Offer a terse response. 1.52e+08. In the year 1995, what is the difference between the Grants(current US$) of Malaysia and Grants(current US$) of Mali?
Your answer should be compact. -1.97e+08. In the year 1995, what is the difference between the Grants(current US$) in Malaysia and Grants(current US$) in Moldova?
Keep it short and to the point. 1.40e+06. In the year 1995, what is the difference between the Grants(current US$) in Mali and Grants(current US$) in Moldova?
Ensure brevity in your answer.  1.99e+08. In the year 1996, what is the difference between the Grants(current US$) in French Polynesia and Grants(current US$) in Malaysia?
Your answer should be compact. 1.32e+08. In the year 1996, what is the difference between the Grants(current US$) in French Polynesia and Grants(current US$) in Mali?
Offer a very short reply. -6.98e+07. In the year 1996, what is the difference between the Grants(current US$) of French Polynesia and Grants(current US$) of Moldova?
Keep it short and to the point. 1.29e+08. In the year 1996, what is the difference between the Grants(current US$) in Malaysia and Grants(current US$) in Mali?
Your answer should be very brief. -2.02e+08. In the year 1996, what is the difference between the Grants(current US$) in Malaysia and Grants(current US$) in Moldova?
Your response must be concise. -3.06e+06. In the year 1996, what is the difference between the Grants(current US$) in Mali and Grants(current US$) in Moldova?
Offer a very short reply. 1.99e+08. In the year 1997, what is the difference between the Grants(current US$) in French Polynesia and Grants(current US$) in Malaysia?
Offer a very short reply. 8.52e+07. In the year 1997, what is the difference between the Grants(current US$) in French Polynesia and Grants(current US$) in Mali?
Ensure brevity in your answer.  -1.13e+08. In the year 1997, what is the difference between the Grants(current US$) of French Polynesia and Grants(current US$) of Moldova?
Ensure brevity in your answer.  8.63e+07. In the year 1997, what is the difference between the Grants(current US$) in Malaysia and Grants(current US$) in Mali?
Give a very brief answer. -1.98e+08. In the year 1997, what is the difference between the Grants(current US$) in Malaysia and Grants(current US$) in Moldova?
Offer a terse response. 1.07e+06. In the year 1997, what is the difference between the Grants(current US$) in Mali and Grants(current US$) in Moldova?
Make the answer very short. 1.99e+08. In the year 1998, what is the difference between the Grants(current US$) in French Polynesia and Grants(current US$) in Malaysia?
Your answer should be very brief. 7.25e+07. In the year 1998, what is the difference between the Grants(current US$) in French Polynesia and Grants(current US$) in Mali?
Your answer should be very brief. -1.08e+08. In the year 1998, what is the difference between the Grants(current US$) of French Polynesia and Grants(current US$) of Moldova?
Provide a succinct answer. 7.36e+07. In the year 1998, what is the difference between the Grants(current US$) of Malaysia and Grants(current US$) of Mali?
Provide a succinct answer. -1.80e+08. In the year 1998, what is the difference between the Grants(current US$) of Malaysia and Grants(current US$) of Moldova?
Your response must be concise. 1.16e+06. In the year 1998, what is the difference between the Grants(current US$) of Mali and Grants(current US$) of Moldova?
Offer a terse response. 1.81e+08. In the year 1999, what is the difference between the Grants(current US$) in French Polynesia and Grants(current US$) in Malaysia?
Ensure brevity in your answer.  4.94e+07. In the year 1999, what is the difference between the Grants(current US$) in French Polynesia and Grants(current US$) in Mali?
Make the answer very short. -1.27e+08. In the year 1999, what is the difference between the Grants(current US$) in French Polynesia and Grants(current US$) in Moldova?
Your response must be concise. 3.93e+07. In the year 1999, what is the difference between the Grants(current US$) of Malaysia and Grants(current US$) of Mali?
Your answer should be very brief. -1.77e+08. In the year 1999, what is the difference between the Grants(current US$) in Malaysia and Grants(current US$) in Moldova?
Offer a very short reply. -1.01e+07. In the year 1999, what is the difference between the Grants(current US$) in Mali and Grants(current US$) in Moldova?
Your response must be concise. 1.67e+08. In the year 2000, what is the difference between the Grants(current US$) in French Polynesia and Grants(current US$) in Malaysia?
Give a very brief answer. 6.92e+07. In the year 2000, what is the difference between the Grants(current US$) in French Polynesia and Grants(current US$) in Mali?
Provide a succinct answer. -1.51e+08. In the year 2000, what is the difference between the Grants(current US$) in French Polynesia and Grants(current US$) in Moldova?
Your answer should be compact. 4.11e+07. In the year 2000, what is the difference between the Grants(current US$) in Malaysia and Grants(current US$) in Mali?
Keep it short and to the point. -2.20e+08. In the year 2000, what is the difference between the Grants(current US$) in Malaysia and Grants(current US$) in Moldova?
Ensure brevity in your answer.  -2.81e+07. In the year 2000, what is the difference between the Grants(current US$) of Mali and Grants(current US$) of Moldova?
Offer a very short reply. 1.92e+08. What is the ratio of the Grants(current US$) in French Polynesia in 1993 to that in 1994?
Your response must be concise. 0.9. What is the ratio of the Grants(current US$) in Malaysia in 1993 to that in 1994?
Ensure brevity in your answer.  1.63. What is the ratio of the Grants(current US$) in Mali in 1993 to that in 1994?
Ensure brevity in your answer.  0.8. What is the ratio of the Grants(current US$) in Moldova in 1993 to that in 1994?
Your response must be concise. 0.56. What is the ratio of the Grants(current US$) in French Polynesia in 1993 to that in 1995?
Offer a very short reply. 0.64. What is the ratio of the Grants(current US$) of Malaysia in 1993 to that in 1995?
Offer a very short reply. 5.31. What is the ratio of the Grants(current US$) of Mali in 1993 to that in 1995?
Your answer should be compact. 0.84. What is the ratio of the Grants(current US$) of Moldova in 1993 to that in 1995?
Make the answer very short. 1.9. What is the ratio of the Grants(current US$) of French Polynesia in 1993 to that in 1996?
Ensure brevity in your answer.  0.74. What is the ratio of the Grants(current US$) of Malaysia in 1993 to that in 1996?
Provide a short and direct response. 8.11. What is the ratio of the Grants(current US$) of Mali in 1993 to that in 1996?
Keep it short and to the point. 0.84. What is the ratio of the Grants(current US$) in Moldova in 1993 to that in 1996?
Ensure brevity in your answer.  1.79. What is the ratio of the Grants(current US$) of French Polynesia in 1993 to that in 1997?
Offer a very short reply. 1.05. What is the ratio of the Grants(current US$) of Malaysia in 1993 to that in 1997?
Offer a terse response. 4.7. What is the ratio of the Grants(current US$) in Mali in 1993 to that in 1997?
Offer a terse response. 0.83. What is the ratio of the Grants(current US$) in Moldova in 1993 to that in 1997?
Give a very brief answer. 1.61. What is the ratio of the Grants(current US$) in French Polynesia in 1993 to that in 1998?
Offer a terse response. 1.1. What is the ratio of the Grants(current US$) in Malaysia in 1993 to that in 1998?
Your response must be concise. 2.81. What is the ratio of the Grants(current US$) of Mali in 1993 to that in 1998?
Ensure brevity in your answer.  0.87. What is the ratio of the Grants(current US$) of Moldova in 1993 to that in 1998?
Give a very brief answer. 0.93. What is the ratio of the Grants(current US$) of French Polynesia in 1993 to that in 1999?
Provide a succinct answer. 1.66. What is the ratio of the Grants(current US$) in Malaysia in 1993 to that in 1999?
Ensure brevity in your answer.  4.64. What is the ratio of the Grants(current US$) of Mali in 1993 to that in 1999?
Give a very brief answer. 0.93. What is the ratio of the Grants(current US$) of Moldova in 1993 to that in 1999?
Keep it short and to the point. 0.81. What is the ratio of the Grants(current US$) in French Polynesia in 1993 to that in 2000?
Keep it short and to the point. 1.32. What is the ratio of the Grants(current US$) in Malaysia in 1993 to that in 2000?
Give a very brief answer. 6.58. What is the ratio of the Grants(current US$) in Mali in 1993 to that in 2000?
Provide a short and direct response. 0.77. What is the ratio of the Grants(current US$) in Moldova in 1993 to that in 2000?
Your answer should be very brief. 0.5. What is the ratio of the Grants(current US$) of French Polynesia in 1994 to that in 1995?
Provide a succinct answer. 0.71. What is the ratio of the Grants(current US$) in Malaysia in 1994 to that in 1995?
Provide a short and direct response. 3.26. What is the ratio of the Grants(current US$) of Mali in 1994 to that in 1995?
Your answer should be very brief. 1.06. What is the ratio of the Grants(current US$) of Moldova in 1994 to that in 1995?
Ensure brevity in your answer.  3.37. What is the ratio of the Grants(current US$) in French Polynesia in 1994 to that in 1996?
Keep it short and to the point. 0.82. What is the ratio of the Grants(current US$) in Malaysia in 1994 to that in 1996?
Offer a very short reply. 4.97. What is the ratio of the Grants(current US$) in Mali in 1994 to that in 1996?
Give a very brief answer. 1.06. What is the ratio of the Grants(current US$) of Moldova in 1994 to that in 1996?
Provide a short and direct response. 3.17. What is the ratio of the Grants(current US$) in French Polynesia in 1994 to that in 1997?
Your response must be concise. 1.16. What is the ratio of the Grants(current US$) in Malaysia in 1994 to that in 1997?
Keep it short and to the point. 2.88. What is the ratio of the Grants(current US$) of Mali in 1994 to that in 1997?
Your response must be concise. 1.05. What is the ratio of the Grants(current US$) in Moldova in 1994 to that in 1997?
Make the answer very short. 2.85. What is the ratio of the Grants(current US$) of French Polynesia in 1994 to that in 1998?
Keep it short and to the point. 1.22. What is the ratio of the Grants(current US$) in Malaysia in 1994 to that in 1998?
Provide a short and direct response. 1.73. What is the ratio of the Grants(current US$) in Mali in 1994 to that in 1998?
Your answer should be compact. 1.1. What is the ratio of the Grants(current US$) of Moldova in 1994 to that in 1998?
Provide a short and direct response. 1.65. What is the ratio of the Grants(current US$) of French Polynesia in 1994 to that in 1999?
Your answer should be compact. 1.84. What is the ratio of the Grants(current US$) of Malaysia in 1994 to that in 1999?
Offer a very short reply. 2.85. What is the ratio of the Grants(current US$) of Mali in 1994 to that in 1999?
Your answer should be very brief. 1.16. What is the ratio of the Grants(current US$) in Moldova in 1994 to that in 1999?
Offer a very short reply. 1.44. What is the ratio of the Grants(current US$) in French Polynesia in 1994 to that in 2000?
Make the answer very short. 1.46. What is the ratio of the Grants(current US$) in Malaysia in 1994 to that in 2000?
Your response must be concise. 4.04. What is the ratio of the Grants(current US$) of Mali in 1994 to that in 2000?
Provide a succinct answer. 0.96. What is the ratio of the Grants(current US$) of Moldova in 1994 to that in 2000?
Your answer should be compact. 0.88. What is the ratio of the Grants(current US$) of French Polynesia in 1995 to that in 1996?
Give a very brief answer. 1.16. What is the ratio of the Grants(current US$) in Malaysia in 1995 to that in 1996?
Keep it short and to the point. 1.53. What is the ratio of the Grants(current US$) in Moldova in 1995 to that in 1996?
Make the answer very short. 0.94. What is the ratio of the Grants(current US$) in French Polynesia in 1995 to that in 1997?
Your response must be concise. 1.65. What is the ratio of the Grants(current US$) of Malaysia in 1995 to that in 1997?
Your answer should be very brief. 0.88. What is the ratio of the Grants(current US$) in Mali in 1995 to that in 1997?
Keep it short and to the point. 0.99. What is the ratio of the Grants(current US$) of Moldova in 1995 to that in 1997?
Give a very brief answer. 0.84. What is the ratio of the Grants(current US$) of French Polynesia in 1995 to that in 1998?
Your answer should be compact. 1.73. What is the ratio of the Grants(current US$) in Malaysia in 1995 to that in 1998?
Keep it short and to the point. 0.53. What is the ratio of the Grants(current US$) of Mali in 1995 to that in 1998?
Offer a terse response. 1.04. What is the ratio of the Grants(current US$) of Moldova in 1995 to that in 1998?
Give a very brief answer. 0.49. What is the ratio of the Grants(current US$) in French Polynesia in 1995 to that in 1999?
Your answer should be very brief. 2.6. What is the ratio of the Grants(current US$) in Malaysia in 1995 to that in 1999?
Make the answer very short. 0.87. What is the ratio of the Grants(current US$) of Mali in 1995 to that in 1999?
Make the answer very short. 1.1. What is the ratio of the Grants(current US$) of Moldova in 1995 to that in 1999?
Make the answer very short. 0.43. What is the ratio of the Grants(current US$) in French Polynesia in 1995 to that in 2000?
Offer a terse response. 2.07. What is the ratio of the Grants(current US$) in Malaysia in 1995 to that in 2000?
Provide a short and direct response. 1.24. What is the ratio of the Grants(current US$) of Mali in 1995 to that in 2000?
Make the answer very short. 0.91. What is the ratio of the Grants(current US$) of Moldova in 1995 to that in 2000?
Your answer should be very brief. 0.26. What is the ratio of the Grants(current US$) in French Polynesia in 1996 to that in 1997?
Provide a short and direct response. 1.42. What is the ratio of the Grants(current US$) in Malaysia in 1996 to that in 1997?
Offer a very short reply. 0.58. What is the ratio of the Grants(current US$) of Moldova in 1996 to that in 1997?
Make the answer very short. 0.9. What is the ratio of the Grants(current US$) of French Polynesia in 1996 to that in 1998?
Your response must be concise. 1.49. What is the ratio of the Grants(current US$) in Malaysia in 1996 to that in 1998?
Offer a terse response. 0.35. What is the ratio of the Grants(current US$) of Mali in 1996 to that in 1998?
Give a very brief answer. 1.04. What is the ratio of the Grants(current US$) in Moldova in 1996 to that in 1998?
Provide a short and direct response. 0.52. What is the ratio of the Grants(current US$) of French Polynesia in 1996 to that in 1999?
Offer a very short reply. 2.24. What is the ratio of the Grants(current US$) in Malaysia in 1996 to that in 1999?
Make the answer very short. 0.57. What is the ratio of the Grants(current US$) in Mali in 1996 to that in 1999?
Ensure brevity in your answer.  1.1. What is the ratio of the Grants(current US$) in Moldova in 1996 to that in 1999?
Your answer should be very brief. 0.45. What is the ratio of the Grants(current US$) of French Polynesia in 1996 to that in 2000?
Your answer should be very brief. 1.78. What is the ratio of the Grants(current US$) in Malaysia in 1996 to that in 2000?
Your answer should be very brief. 0.81. What is the ratio of the Grants(current US$) of Mali in 1996 to that in 2000?
Your answer should be very brief. 0.91. What is the ratio of the Grants(current US$) of Moldova in 1996 to that in 2000?
Provide a succinct answer. 0.28. What is the ratio of the Grants(current US$) in French Polynesia in 1997 to that in 1998?
Offer a terse response. 1.05. What is the ratio of the Grants(current US$) of Malaysia in 1997 to that in 1998?
Your response must be concise. 0.6. What is the ratio of the Grants(current US$) in Mali in 1997 to that in 1998?
Give a very brief answer. 1.05. What is the ratio of the Grants(current US$) of Moldova in 1997 to that in 1998?
Offer a very short reply. 0.58. What is the ratio of the Grants(current US$) of French Polynesia in 1997 to that in 1999?
Provide a succinct answer. 1.58. What is the ratio of the Grants(current US$) in Malaysia in 1997 to that in 1999?
Your response must be concise. 0.99. What is the ratio of the Grants(current US$) of Mali in 1997 to that in 1999?
Your answer should be very brief. 1.11. What is the ratio of the Grants(current US$) of Moldova in 1997 to that in 1999?
Provide a succinct answer. 0.5. What is the ratio of the Grants(current US$) in French Polynesia in 1997 to that in 2000?
Offer a terse response. 1.25. What is the ratio of the Grants(current US$) of Malaysia in 1997 to that in 2000?
Offer a terse response. 1.4. What is the ratio of the Grants(current US$) of Mali in 1997 to that in 2000?
Make the answer very short. 0.92. What is the ratio of the Grants(current US$) of Moldova in 1997 to that in 2000?
Give a very brief answer. 0.31. What is the ratio of the Grants(current US$) of French Polynesia in 1998 to that in 1999?
Offer a terse response. 1.51. What is the ratio of the Grants(current US$) in Malaysia in 1998 to that in 1999?
Give a very brief answer. 1.65. What is the ratio of the Grants(current US$) of Mali in 1998 to that in 1999?
Give a very brief answer. 1.06. What is the ratio of the Grants(current US$) in Moldova in 1998 to that in 1999?
Ensure brevity in your answer.  0.87. What is the ratio of the Grants(current US$) of French Polynesia in 1998 to that in 2000?
Ensure brevity in your answer.  1.2. What is the ratio of the Grants(current US$) of Malaysia in 1998 to that in 2000?
Your answer should be compact. 2.34. What is the ratio of the Grants(current US$) of Mali in 1998 to that in 2000?
Your response must be concise. 0.88. What is the ratio of the Grants(current US$) in Moldova in 1998 to that in 2000?
Provide a succinct answer. 0.54. What is the ratio of the Grants(current US$) in French Polynesia in 1999 to that in 2000?
Your answer should be compact. 0.79. What is the ratio of the Grants(current US$) in Malaysia in 1999 to that in 2000?
Provide a succinct answer. 1.42. What is the ratio of the Grants(current US$) in Mali in 1999 to that in 2000?
Your answer should be compact. 0.83. What is the ratio of the Grants(current US$) of Moldova in 1999 to that in 2000?
Make the answer very short. 0.62. What is the difference between the highest and the second highest Grants(current US$) of French Polynesia?
Offer a terse response. 2.23e+07. What is the difference between the highest and the second highest Grants(current US$) of Malaysia?
Make the answer very short. 2.28e+07. What is the difference between the highest and the second highest Grants(current US$) of Mali?
Ensure brevity in your answer.  8.02e+06. What is the difference between the highest and the second highest Grants(current US$) of Moldova?
Your response must be concise. 4.30e+06. What is the difference between the highest and the lowest Grants(current US$) of French Polynesia?
Provide a succinct answer. 9.94e+07. What is the difference between the highest and the lowest Grants(current US$) of Malaysia?
Ensure brevity in your answer.  5.17e+07. What is the difference between the highest and the lowest Grants(current US$) of Mali?
Your answer should be very brief. 5.32e+07. What is the difference between the highest and the lowest Grants(current US$) of Moldova?
Offer a very short reply. 2.73e+07. 